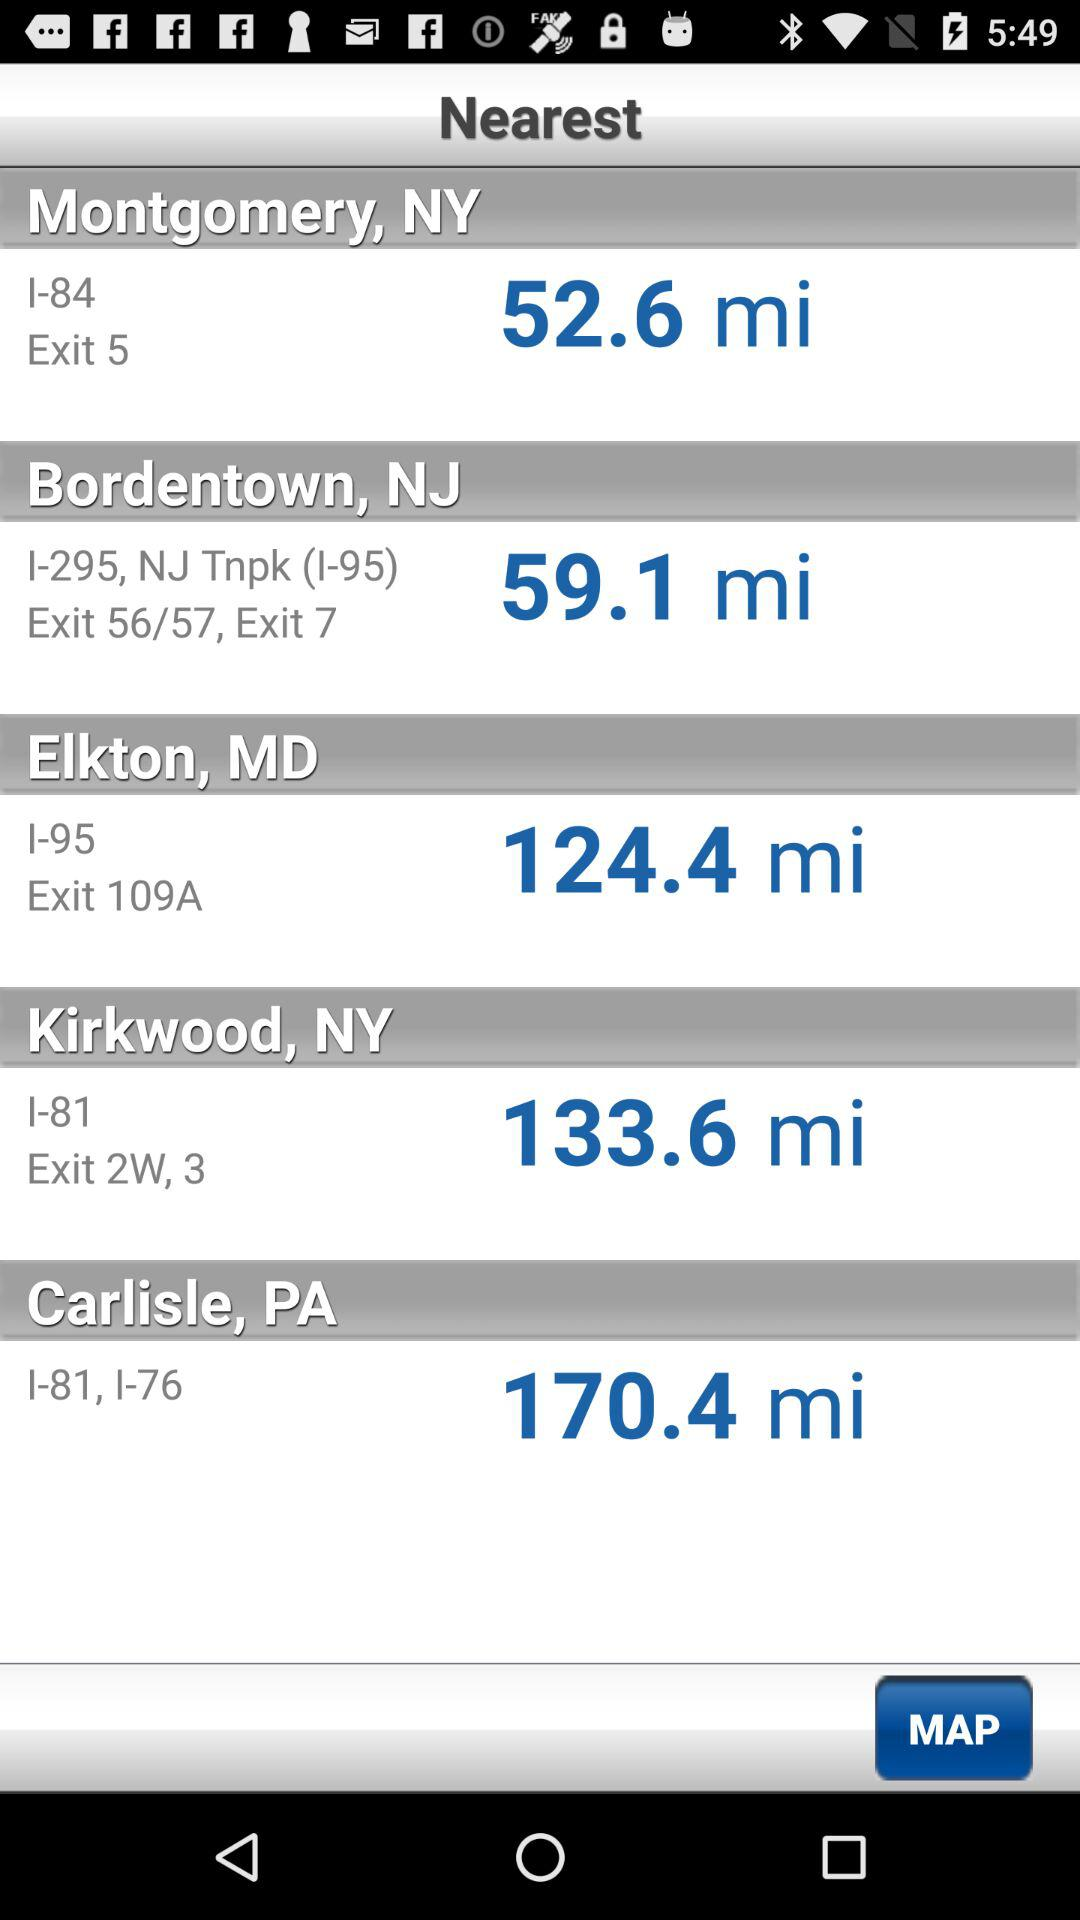Which location has the shortest distance to the user?
Answer the question using a single word or phrase. Montgomery, NY 